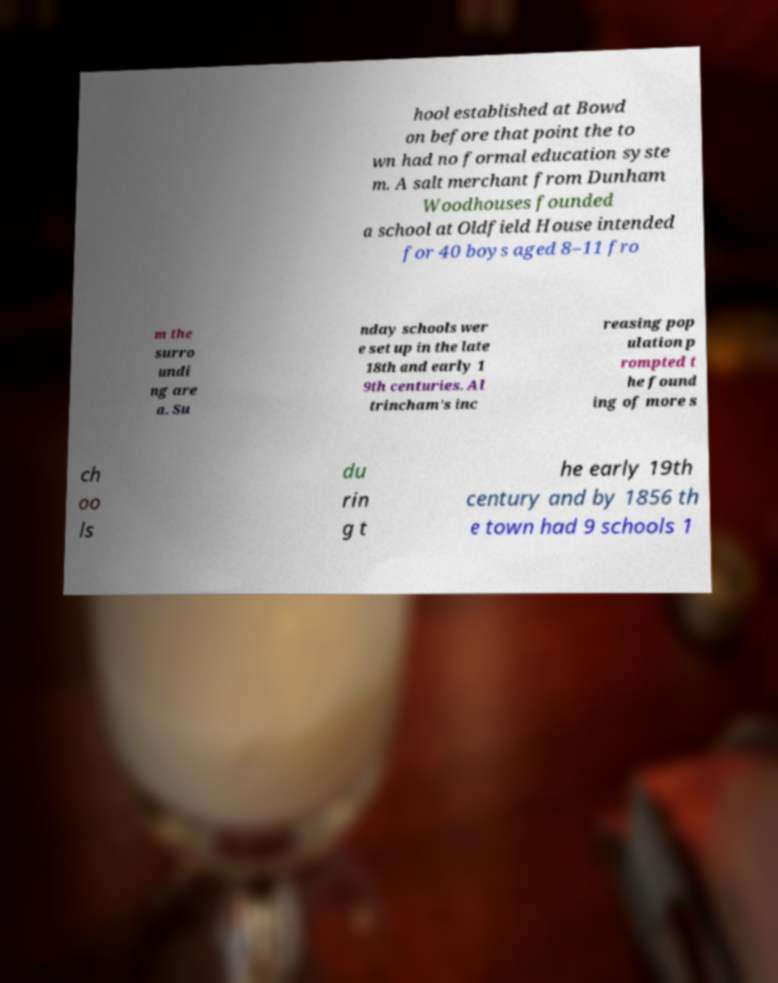For documentation purposes, I need the text within this image transcribed. Could you provide that? hool established at Bowd on before that point the to wn had no formal education syste m. A salt merchant from Dunham Woodhouses founded a school at Oldfield House intended for 40 boys aged 8–11 fro m the surro undi ng are a. Su nday schools wer e set up in the late 18th and early 1 9th centuries. Al trincham's inc reasing pop ulation p rompted t he found ing of more s ch oo ls du rin g t he early 19th century and by 1856 th e town had 9 schools 1 